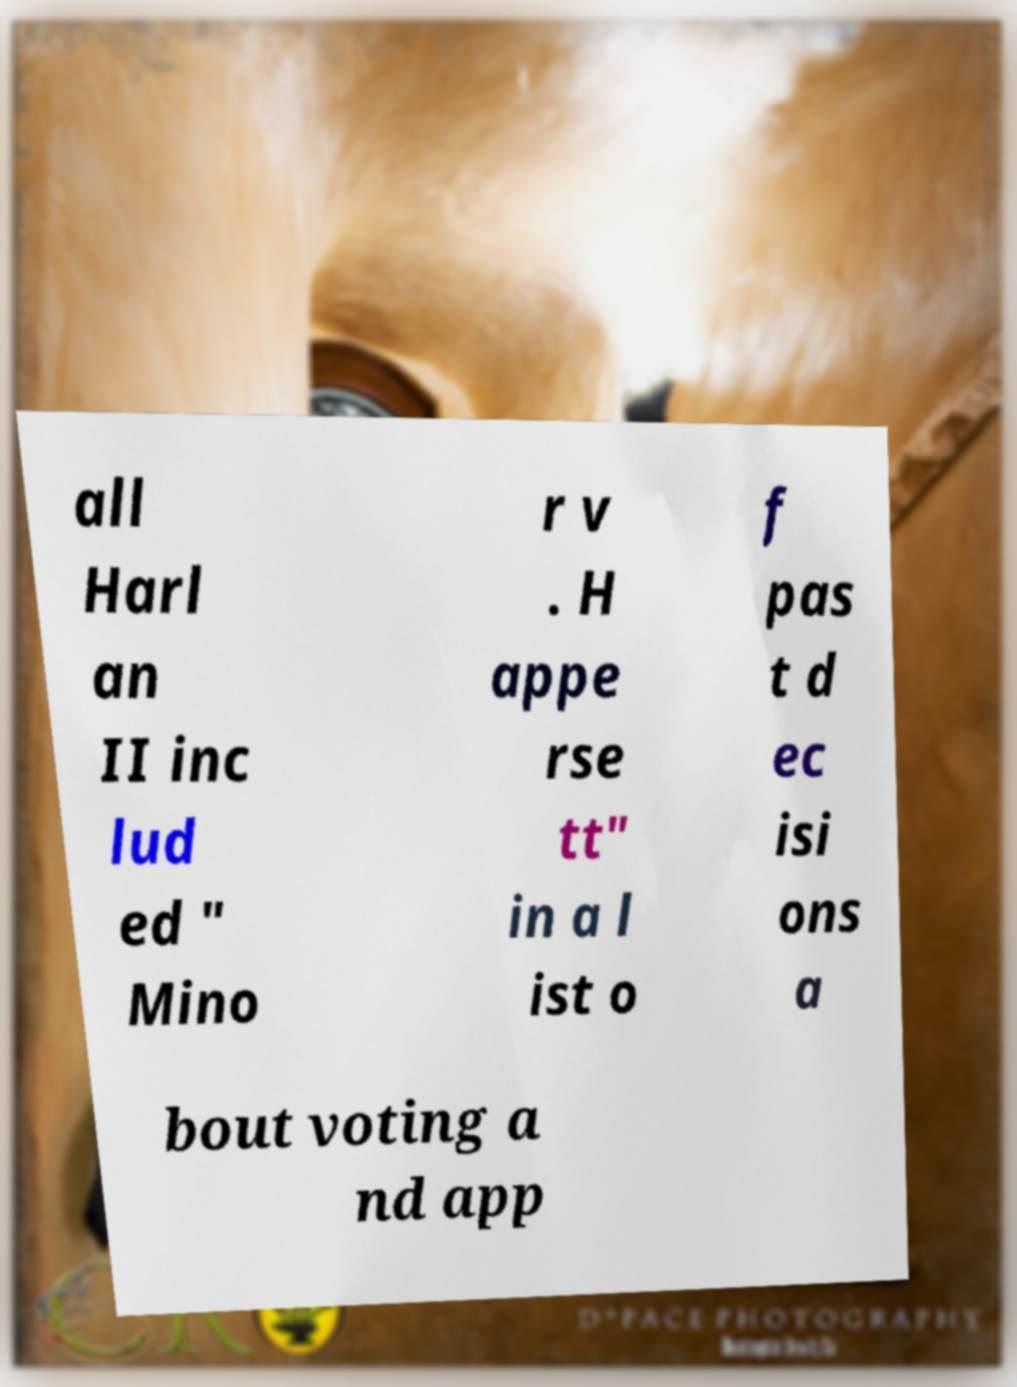I need the written content from this picture converted into text. Can you do that? all Harl an II inc lud ed " Mino r v . H appe rse tt" in a l ist o f pas t d ec isi ons a bout voting a nd app 